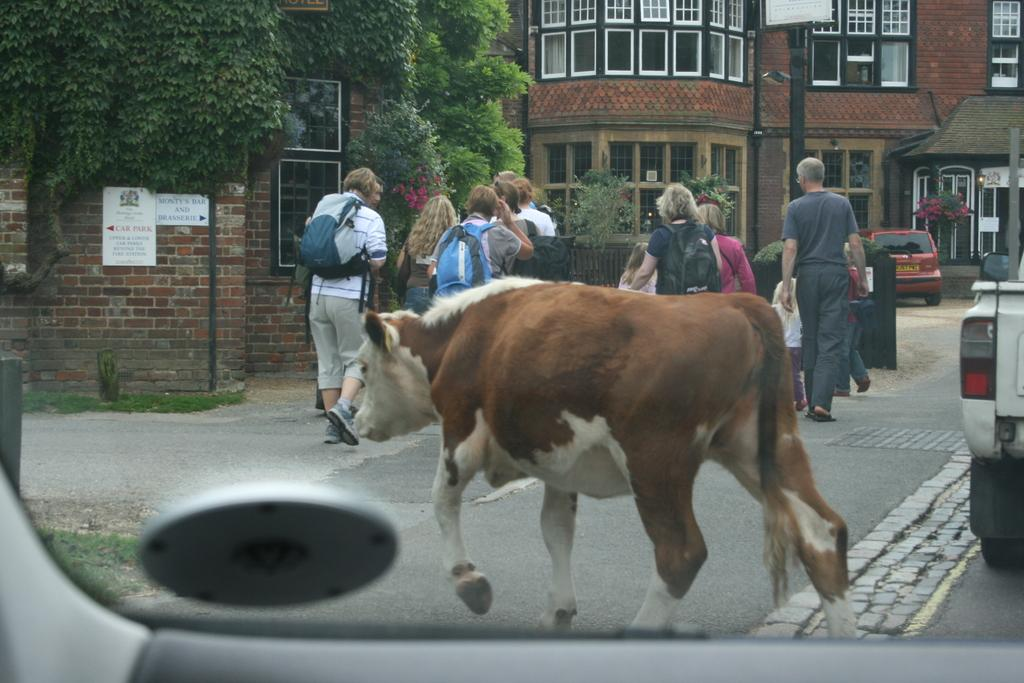What is the main subject in the center of the image? There is a cow in the center of the image. Where is the cow located? The cow is on the road. What object can be seen at the bottom of the image? There is a car mirror at the bottom of the image. What can be seen in the background of the image? Persons, trees, buildings, and flowers are visible in the background. What type of gold is being copied by the persons in the background? There is no gold or copying activity present in the image. How many books can be seen in the image? There are no books visible in the image. 